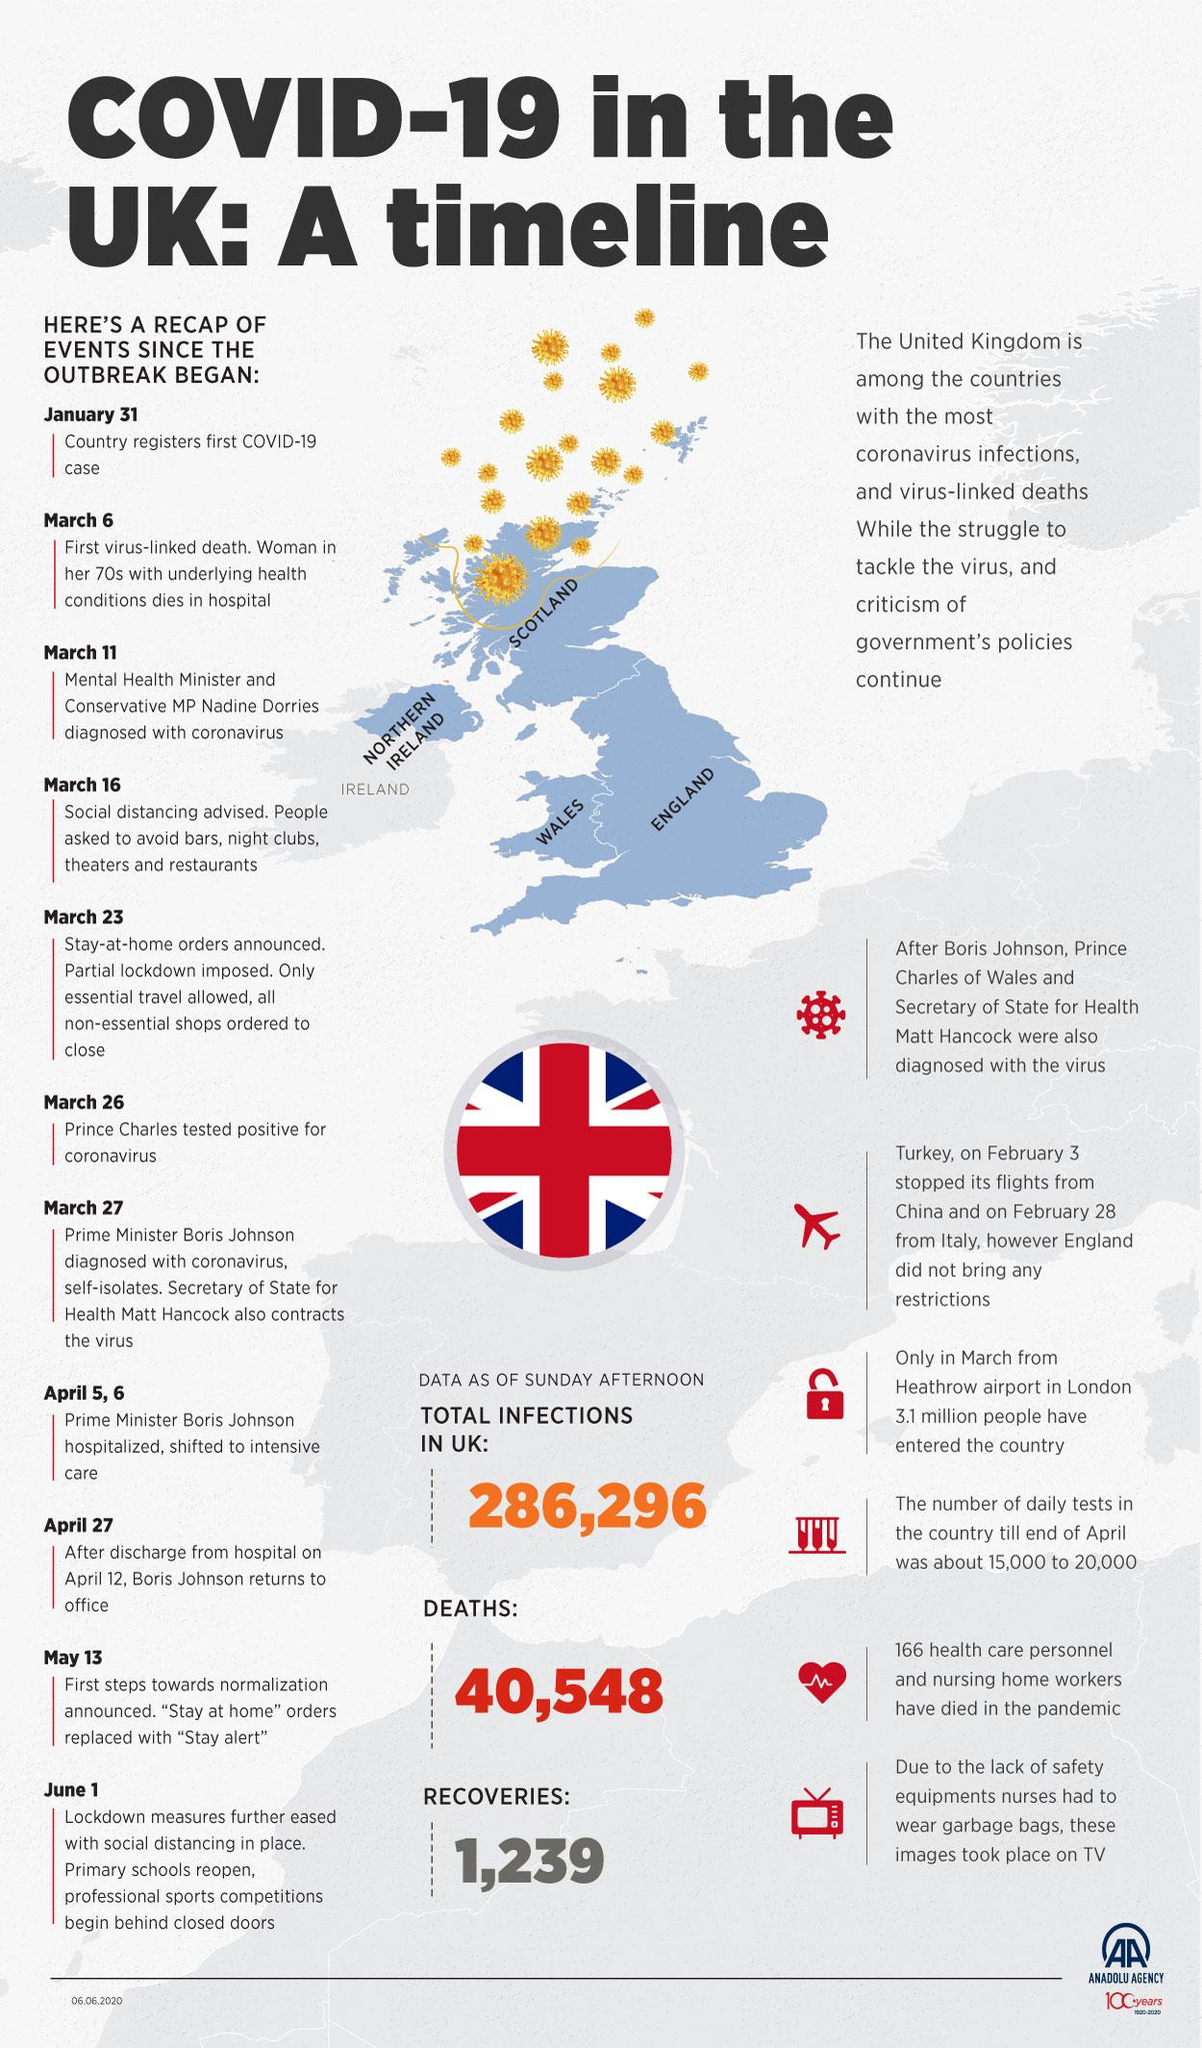Specify some key components in this picture. On April 27, Boris Johnson returned to office. The total number of reported deaths in the UK is 40,548. Prince Charles contracted the virus. On March 23, a partial lockdown was imposed in England. Turkey has suspended flights from China and Italy due to the COVID-19 pandemic. 